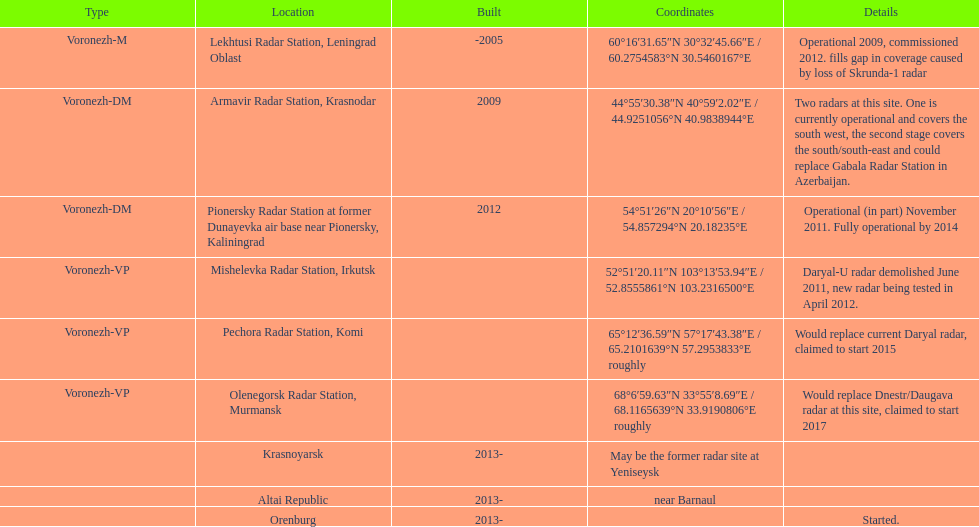How many voronezh radars were built before 2010? 2. 